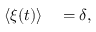Convert formula to latex. <formula><loc_0><loc_0><loc_500><loc_500>\begin{array} { r l } { \langle \xi ( t ) \rangle } & = \delta , } \end{array}</formula> 